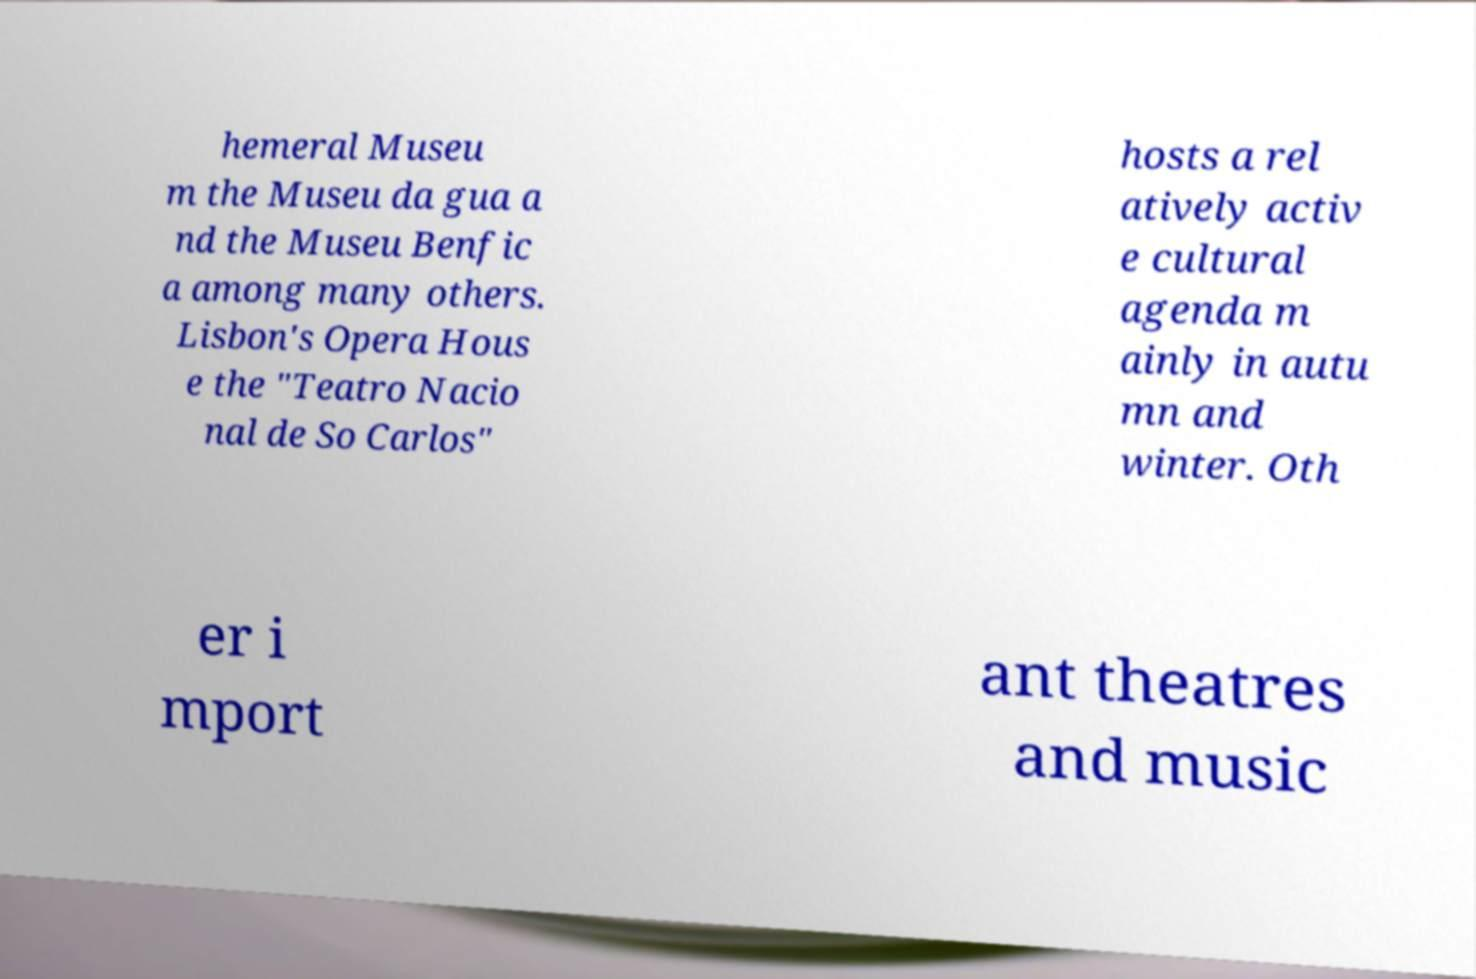I need the written content from this picture converted into text. Can you do that? hemeral Museu m the Museu da gua a nd the Museu Benfic a among many others. Lisbon's Opera Hous e the "Teatro Nacio nal de So Carlos" hosts a rel atively activ e cultural agenda m ainly in autu mn and winter. Oth er i mport ant theatres and music 